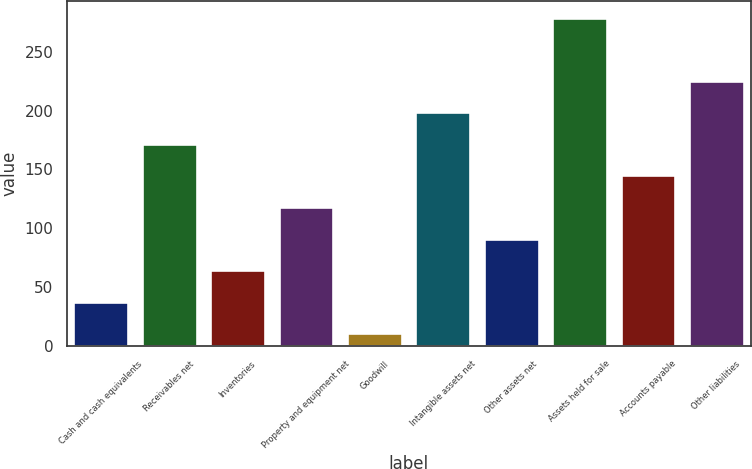Convert chart. <chart><loc_0><loc_0><loc_500><loc_500><bar_chart><fcel>Cash and cash equivalents<fcel>Receivables net<fcel>Inventories<fcel>Property and equipment net<fcel>Goodwill<fcel>Intangible assets net<fcel>Other assets net<fcel>Assets held for sale<fcel>Accounts payable<fcel>Other liabilities<nl><fcel>37.71<fcel>171.76<fcel>64.52<fcel>118.14<fcel>10.9<fcel>198.57<fcel>91.33<fcel>279<fcel>144.95<fcel>225.38<nl></chart> 